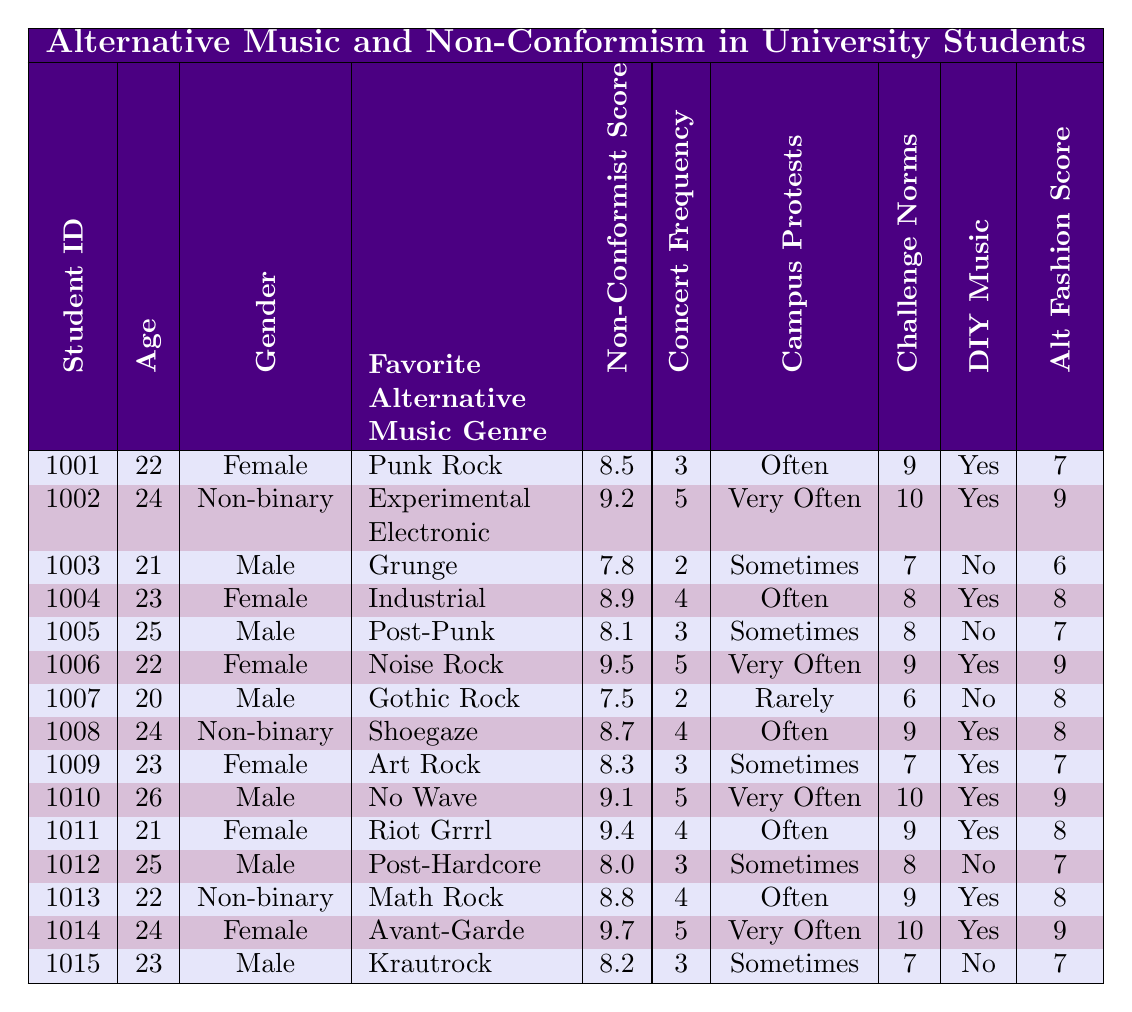What is the Non-Conformist Attitude Score for Student ID 1006? The Non-Conformist Attitude Score is listed directly under the corresponding Student ID row in the table. For Student ID 1006, the score is 9.5.
Answer: 9.5 How many students have a favorite genre of Punk Rock? The table indicates that there is only one instance of the genre Punk Rock, as we can see it in the Favorite Alternative Music Genre column under Student ID 1001.
Answer: 1 What is the average Non-Conformist Attitude Score for all students? To calculate the average, we sum the Non-Conformist Scores (8.5 + 9.2 + 7.8 + 8.9 + 8.1 + 9.5 + 7.5 + 8.7 + 8.3 + 9.1 + 9.4 + 8.0 + 8.8 + 9.7 + 8.2) = 133.1 and divide by the number of students (15), giving us an average of 133.1/15 = 8.87.
Answer: 8.87 Which gender has the highest average Non-Conformist Attitude Score? First, we segregate the scores by gender: Female: (8.5, 8.9, 9.5, 8.7, 9.4, 8.0, 9.7) = 62.7 / 7 = 8.96; Male: (7.8, 8.1, 7.5, 9.1, 8.2) = 40.7 / 5 = 8.14; Non-binary: (9.2, 8.8) = 18.0 / 2 = 9.0. Comparing these averages, Female has the highest average score.
Answer: Female Is there a student who participates in campus protests and scores more than 9 on the Non-Conformist Attitude Score? We review the Campus Protests column alongside the Non-Conformist Scores. Students with "Yes" in Campus Protests column and scores above 9 are 1002, 1006, 1010, 1011, 1014. Therefore, there are students who meet the criteria.
Answer: Yes What is the most common frequency of attending underground concerts among students with a Non-Conformist Score above 9? We look at the concert frequency for students scoring above 9: Students 1002, 1006, 1010, 1011, 1014 – four of them attend "Very Often" (1002, 1006, 1010, 1014) and one attends "Often" (10011), so the most common frequency is "Very Often".
Answer: Very Often Do the students who create DIY music also have a higher Non-Conformist Attitude Score? Checking the DIY Music Creation column where students "Yes" and their scores indicates: Students 1002 (9.2), 1006 (9.5), 1008 (8.7), 1010 (9.1), 1011 (9.4), 1014 (9.7) versus other students with scores below (8.5, 7.8, etc.). Majority of those creating DIY music have scores above 9, suggesting a positive correlation.
Answer: Yes What percentage of students identify as Male in this data set? There are 15 students total, and 7 identify as Male (counts from the Gender column), so the percentage is (7/15)*100 = 46.67%.
Answer: 46.67% 